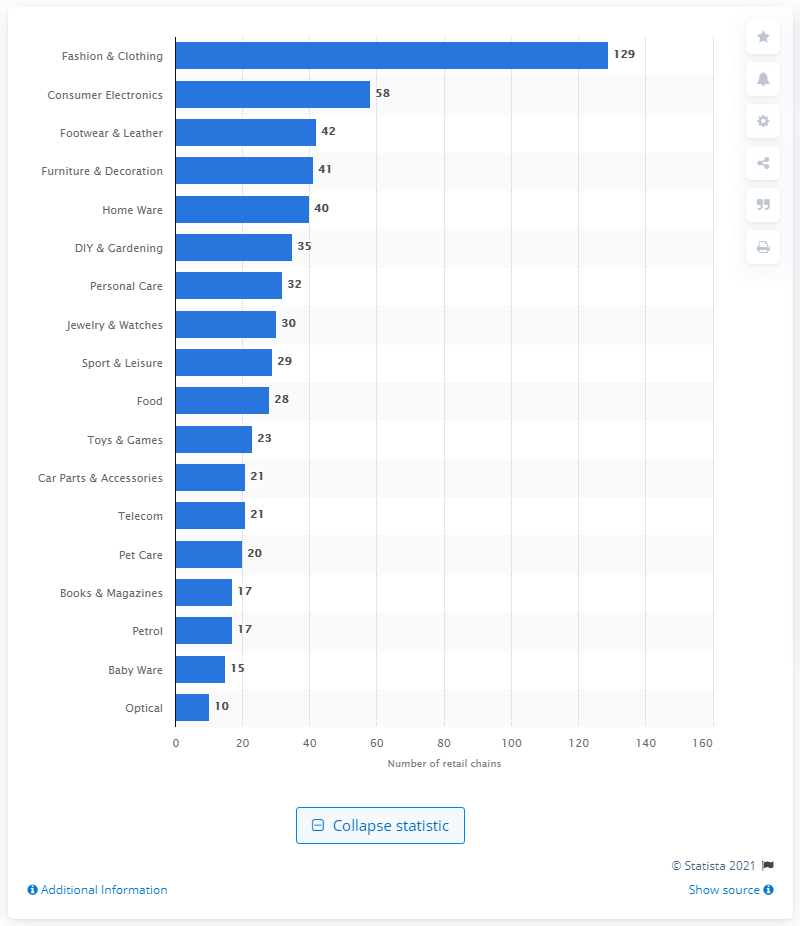Identify some key points in this picture. In 2020, there were 58 retail chains in the consumer electronics sector in the UK. 